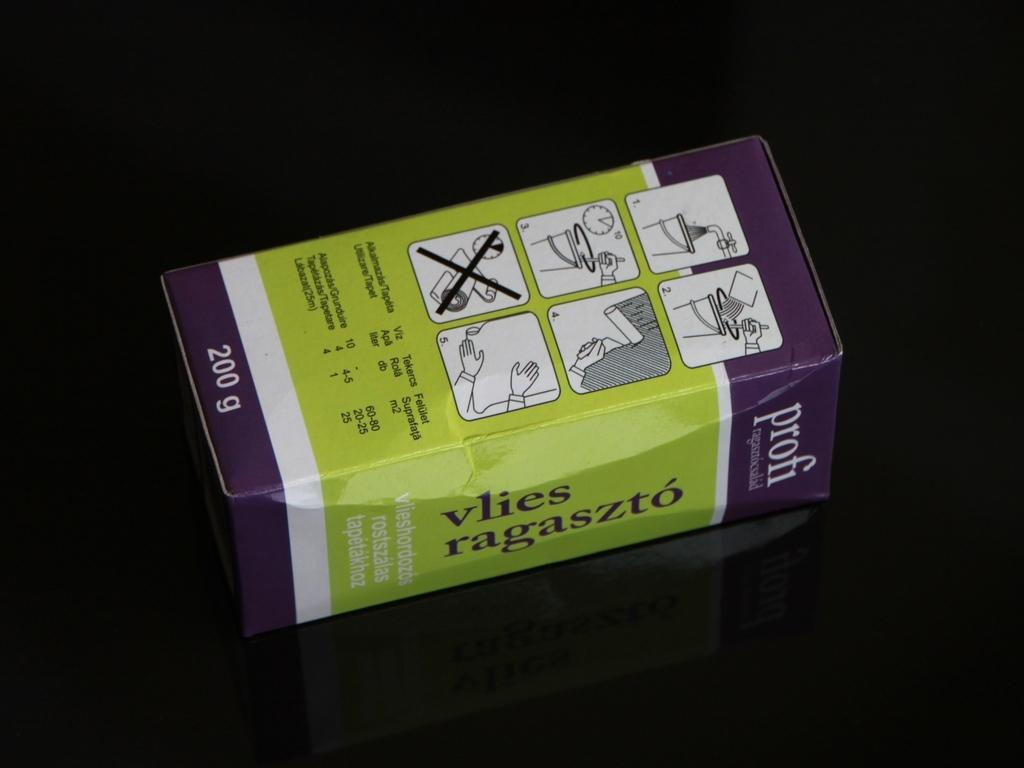<image>
Provide a brief description of the given image. A green box that says vlies ragaszto is on a dark surface. 